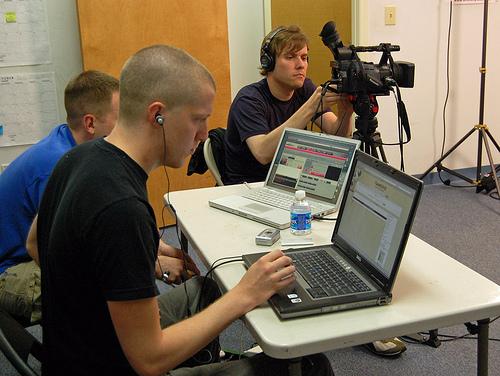Is this a celebration?
Quick response, please. No. What color is the sock of the men?
Give a very brief answer. White. Is someone using the laptop?
Concise answer only. Yes. How many computers are in this picture?
Give a very brief answer. 2. Are all the people in the photograph smiling?
Give a very brief answer. No. Is the man standing looking at the camera?
Be succinct. No. What branch of the military is the man from?
Quick response, please. Army. What are these boys doing?
Quick response, please. Designing. How many laptops are on the table?
Quick response, please. 2. How many laptops are there?
Answer briefly. 2. How many men are there?
Concise answer only. 3. Who is holding the computer?
Quick response, please. Man. How many people?
Answer briefly. 3. Are these men professionals?
Be succinct. Yes. Which screen specifically is the man looking at?
Short answer required. Laptop. What  type of box is above the laptop?
Concise answer only. Camera. Are they sitting at a desk?
Short answer required. Yes. Is the girl using the internet?
Be succinct. No. What is the laptop sitting on?
Quick response, please. Table. Could this person be a student?
Be succinct. Yes. What is on the mans lap?
Short answer required. Laptop. How many people are using headphones?
Answer briefly. 2. Are they having lunch in a classroom?
Give a very brief answer. No. 